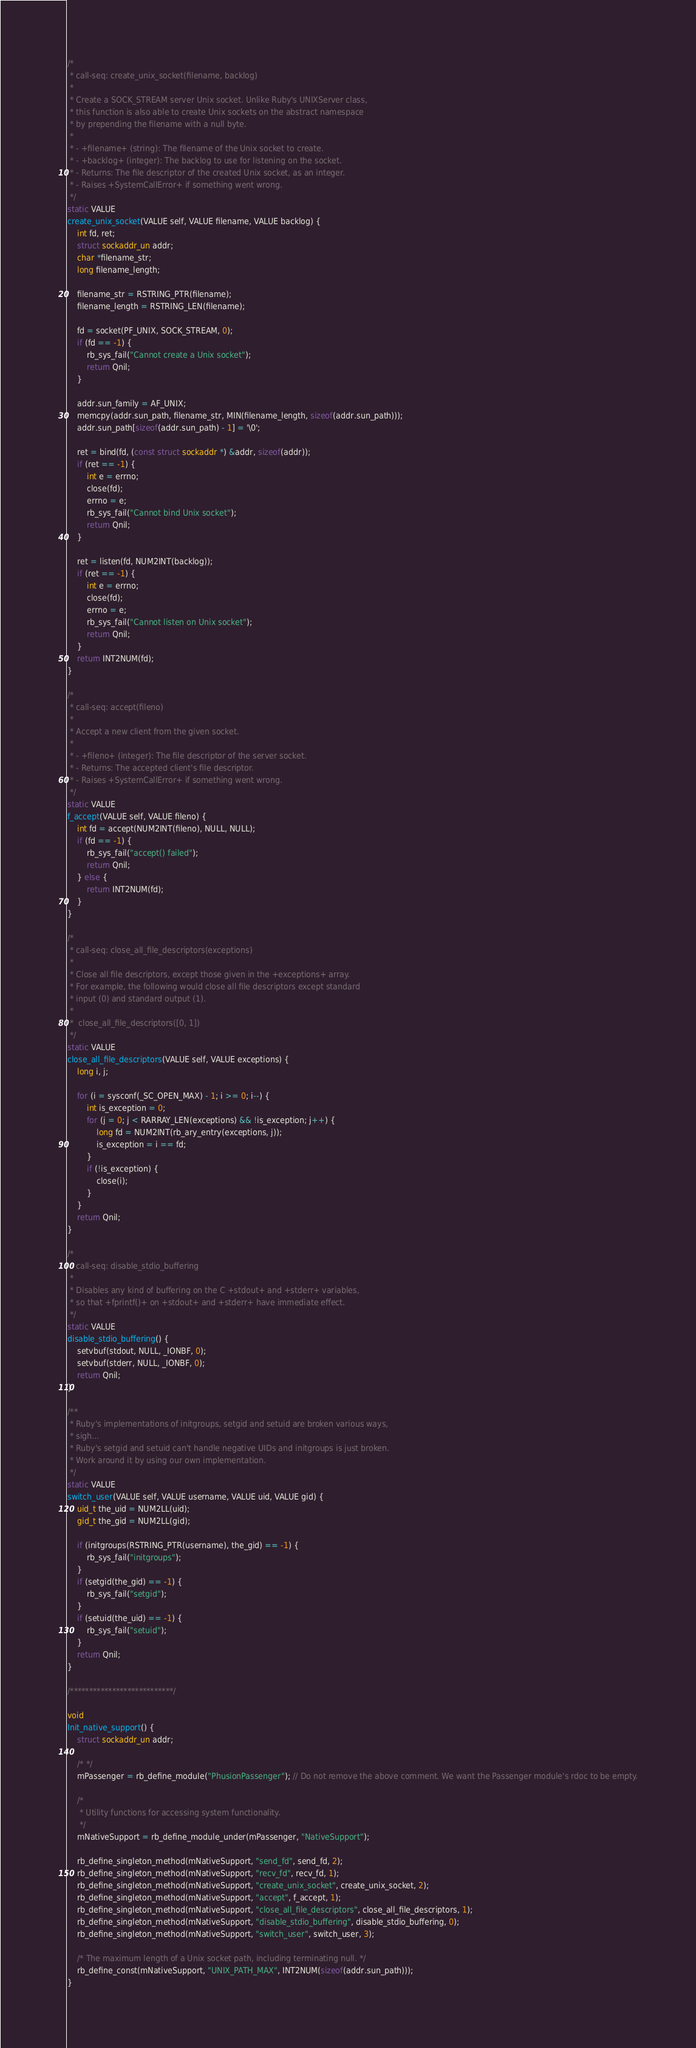<code> <loc_0><loc_0><loc_500><loc_500><_C_>
/*
 * call-seq: create_unix_socket(filename, backlog)
 *
 * Create a SOCK_STREAM server Unix socket. Unlike Ruby's UNIXServer class,
 * this function is also able to create Unix sockets on the abstract namespace
 * by prepending the filename with a null byte.
 *
 * - +filename+ (string): The filename of the Unix socket to create.
 * - +backlog+ (integer): The backlog to use for listening on the socket.
 * - Returns: The file descriptor of the created Unix socket, as an integer.
 * - Raises +SystemCallError+ if something went wrong.
 */
static VALUE
create_unix_socket(VALUE self, VALUE filename, VALUE backlog) {
	int fd, ret;
	struct sockaddr_un addr;
	char *filename_str;
	long filename_length;
	
	filename_str = RSTRING_PTR(filename);
	filename_length = RSTRING_LEN(filename);
	
	fd = socket(PF_UNIX, SOCK_STREAM, 0);
	if (fd == -1) {
		rb_sys_fail("Cannot create a Unix socket");
		return Qnil;
	}
	
	addr.sun_family = AF_UNIX;
	memcpy(addr.sun_path, filename_str, MIN(filename_length, sizeof(addr.sun_path)));
	addr.sun_path[sizeof(addr.sun_path) - 1] = '\0';
	
	ret = bind(fd, (const struct sockaddr *) &addr, sizeof(addr));
	if (ret == -1) {
		int e = errno;
		close(fd);
		errno = e;
		rb_sys_fail("Cannot bind Unix socket");
		return Qnil;
	}
	
	ret = listen(fd, NUM2INT(backlog));
	if (ret == -1) {
		int e = errno;
		close(fd);
		errno = e;
		rb_sys_fail("Cannot listen on Unix socket");
		return Qnil;
	}
	return INT2NUM(fd);
}

/*
 * call-seq: accept(fileno)
 *
 * Accept a new client from the given socket.
 *
 * - +fileno+ (integer): The file descriptor of the server socket.
 * - Returns: The accepted client's file descriptor.
 * - Raises +SystemCallError+ if something went wrong.
 */
static VALUE
f_accept(VALUE self, VALUE fileno) {
	int fd = accept(NUM2INT(fileno), NULL, NULL);
	if (fd == -1) {
		rb_sys_fail("accept() failed");
		return Qnil;
	} else {
		return INT2NUM(fd);
	}
}

/*
 * call-seq: close_all_file_descriptors(exceptions)
 *
 * Close all file descriptors, except those given in the +exceptions+ array.
 * For example, the following would close all file descriptors except standard
 * input (0) and standard output (1).
 *
 *  close_all_file_descriptors([0, 1])
 */
static VALUE
close_all_file_descriptors(VALUE self, VALUE exceptions) {
	long i, j;
	
	for (i = sysconf(_SC_OPEN_MAX) - 1; i >= 0; i--) {
		int is_exception = 0;
		for (j = 0; j < RARRAY_LEN(exceptions) && !is_exception; j++) {
			long fd = NUM2INT(rb_ary_entry(exceptions, j));
			is_exception = i == fd;
		}
		if (!is_exception) {
			close(i);
		}
	}
	return Qnil;
}

/*
 * call-seq: disable_stdio_buffering
 *
 * Disables any kind of buffering on the C +stdout+ and +stderr+ variables,
 * so that +fprintf()+ on +stdout+ and +stderr+ have immediate effect.
 */
static VALUE
disable_stdio_buffering() {
	setvbuf(stdout, NULL, _IONBF, 0);
	setvbuf(stderr, NULL, _IONBF, 0);
	return Qnil;
}

/**
 * Ruby's implementations of initgroups, setgid and setuid are broken various ways,
 * sigh...
 * Ruby's setgid and setuid can't handle negative UIDs and initgroups is just broken.
 * Work around it by using our own implementation.
 */
static VALUE
switch_user(VALUE self, VALUE username, VALUE uid, VALUE gid) {
	uid_t the_uid = NUM2LL(uid);
	gid_t the_gid = NUM2LL(gid);

	if (initgroups(RSTRING_PTR(username), the_gid) == -1) {
		rb_sys_fail("initgroups");
	}
	if (setgid(the_gid) == -1) {
		rb_sys_fail("setgid");
	}
	if (setuid(the_uid) == -1) {
		rb_sys_fail("setuid");
	}
	return Qnil;
}

/***************************/

void
Init_native_support() {
	struct sockaddr_un addr;
	
	/* */
	mPassenger = rb_define_module("PhusionPassenger"); // Do not remove the above comment. We want the Passenger module's rdoc to be empty.
	
	/*
	 * Utility functions for accessing system functionality.
	 */
	mNativeSupport = rb_define_module_under(mPassenger, "NativeSupport");
	
	rb_define_singleton_method(mNativeSupport, "send_fd", send_fd, 2);
	rb_define_singleton_method(mNativeSupport, "recv_fd", recv_fd, 1);
	rb_define_singleton_method(mNativeSupport, "create_unix_socket", create_unix_socket, 2);
	rb_define_singleton_method(mNativeSupport, "accept", f_accept, 1);
	rb_define_singleton_method(mNativeSupport, "close_all_file_descriptors", close_all_file_descriptors, 1);
	rb_define_singleton_method(mNativeSupport, "disable_stdio_buffering", disable_stdio_buffering, 0);
	rb_define_singleton_method(mNativeSupport, "switch_user", switch_user, 3);
	
	/* The maximum length of a Unix socket path, including terminating null. */
	rb_define_const(mNativeSupport, "UNIX_PATH_MAX", INT2NUM(sizeof(addr.sun_path)));
}
</code> 